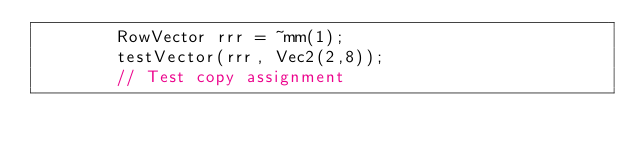Convert code to text. <code><loc_0><loc_0><loc_500><loc_500><_C++_>        RowVector rrr = ~mm(1); 
        testVector(rrr, Vec2(2,8));
        // Test copy assignment</code> 